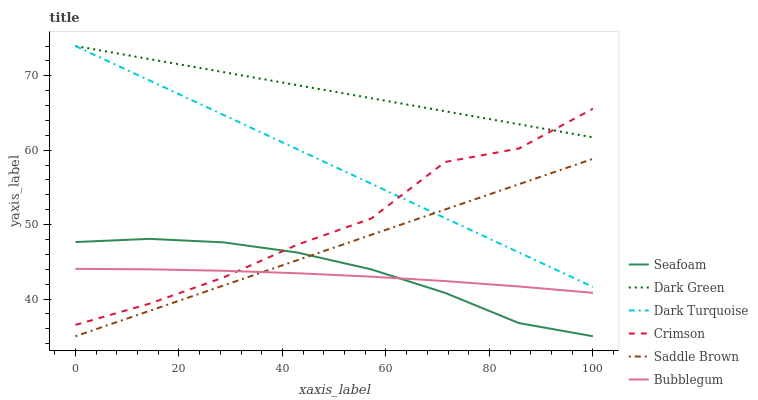Does Bubblegum have the minimum area under the curve?
Answer yes or no. Yes. Does Dark Green have the maximum area under the curve?
Answer yes or no. Yes. Does Seafoam have the minimum area under the curve?
Answer yes or no. No. Does Seafoam have the maximum area under the curve?
Answer yes or no. No. Is Saddle Brown the smoothest?
Answer yes or no. Yes. Is Crimson the roughest?
Answer yes or no. Yes. Is Seafoam the smoothest?
Answer yes or no. No. Is Seafoam the roughest?
Answer yes or no. No. Does Seafoam have the lowest value?
Answer yes or no. Yes. Does Bubblegum have the lowest value?
Answer yes or no. No. Does Dark Green have the highest value?
Answer yes or no. Yes. Does Seafoam have the highest value?
Answer yes or no. No. Is Seafoam less than Dark Green?
Answer yes or no. Yes. Is Dark Turquoise greater than Seafoam?
Answer yes or no. Yes. Does Bubblegum intersect Crimson?
Answer yes or no. Yes. Is Bubblegum less than Crimson?
Answer yes or no. No. Is Bubblegum greater than Crimson?
Answer yes or no. No. Does Seafoam intersect Dark Green?
Answer yes or no. No. 